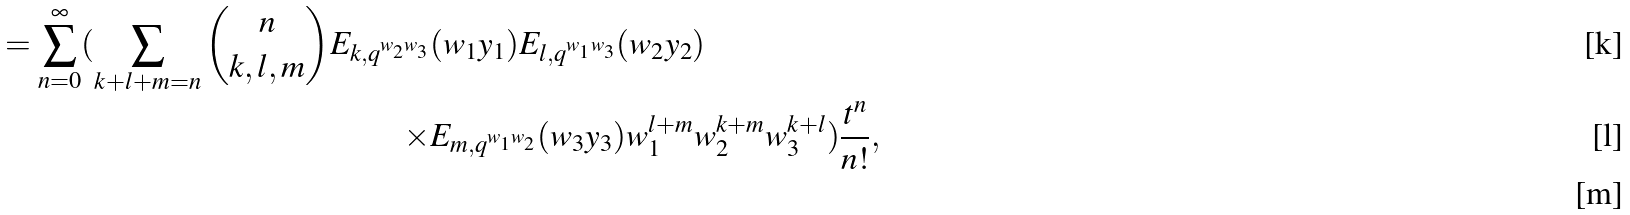<formula> <loc_0><loc_0><loc_500><loc_500>= \sum _ { n = 0 } ^ { \infty } ( \sum _ { k + l + m = n } \binom { n } { k , l , m } E _ { k , q ^ { w _ { 2 } w _ { 3 } } } & ( w _ { 1 } y _ { 1 } ) E _ { l , q ^ { w _ { 1 } w _ { 3 } } } ( w _ { 2 } y _ { 2 } ) \\ \times & E _ { m , q ^ { w _ { 1 } w _ { 2 } } } ( w _ { 3 } y _ { 3 } ) w _ { 1 } ^ { l + m } w _ { 2 } ^ { k + m } w _ { 3 } ^ { k + l } ) \frac { t ^ { n } } { n ! } , \quad \\</formula> 